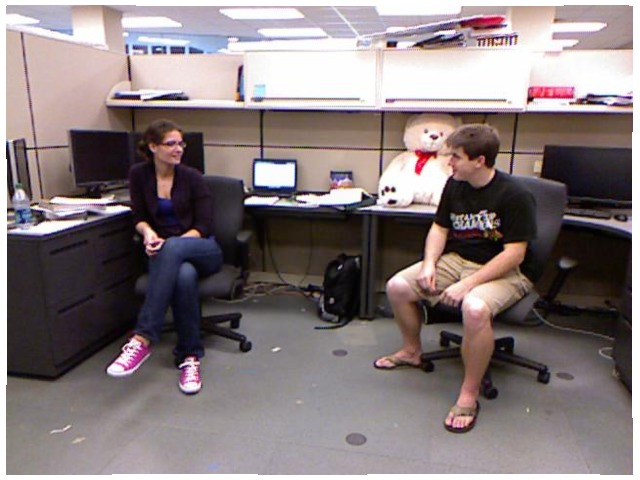<image>
Is the man on the chair? Yes. Looking at the image, I can see the man is positioned on top of the chair, with the chair providing support. Where is the teddy bear in relation to the man? Is it on the man? No. The teddy bear is not positioned on the man. They may be near each other, but the teddy bear is not supported by or resting on top of the man. Is there a teddy bear behind the man? Yes. From this viewpoint, the teddy bear is positioned behind the man, with the man partially or fully occluding the teddy bear. Is the bear behind the person? Yes. From this viewpoint, the bear is positioned behind the person, with the person partially or fully occluding the bear. Where is the teddy in relation to the person? Is it behind the person? Yes. From this viewpoint, the teddy is positioned behind the person, with the person partially or fully occluding the teddy. Where is the man in relation to the chair? Is it behind the chair? No. The man is not behind the chair. From this viewpoint, the man appears to be positioned elsewhere in the scene. Is there a wire in the wall? Yes. The wire is contained within or inside the wall, showing a containment relationship. Is there a woman next to the computer? Yes. The woman is positioned adjacent to the computer, located nearby in the same general area. 